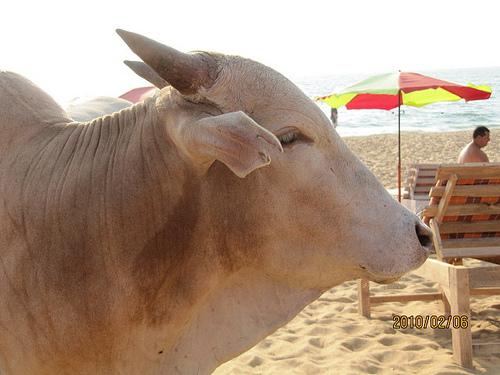What characteristics of the cow's horns are mentioned? The cow's horns are sharp and pointy. Identify the pieces of furniture located on the beach. There is a wooden beach chair and a lay out chair on the sand. What type of umbrella is present on the beach and what are its colors? A red and yellow beach umbrella is present on the beach. What type of date stamp is present in the image, and what are its components? There is a date stamp with the year 2010, the month 02, and the date 06. What animal is on the beach and what color is it? There is a large light brown cow on the beach. What interesting characteristics does the cow's ear have? The cow's ear has a piece clipped off. Describe the sandy area on the beach. The sandy area on the beach is soft and measures 157 pixels wide and 157 pixels tall. Which features of the cow's face are described in the image? The cow's eye, nostril, mouth, ear, and horns are described in the image. What is the primary task the human is performing in the image? The man is sitting on a bench at the beach. What are the missing elements on the man sitting on the beach? The man has dark hair and is not wearing a shirt. Describe the appearance of the man sitting on the bench. The man has dark hair and no shirt on. What is the number on the date stamp? 2010-02-06 What is the man sitting on at the beach? A wooden beach chair Which animal can be found on the beach in the image? Brown Brahma cow Write a sentence explaining the condition of the Brahma cow's ear. The Brahma cow's ear has a piece clipped off. What type of animal is on the beach, and how can you recognize it? A large and light brown Brahma cow with sharp pointy horns and a fatty deposit hump is on the beach. Which of the following materials make up the beach chair: plastic, wood or metal? Wood What are the unique features of the Brahma cow in the image? Sharp and pointy horns, clipped ear, pink nose with black nostril, white eyelashes, and a fatty deposit hump. What color is the umbrella on the beach? Yellow and red Is the umbrella in the image a beach umbrella? Provide a brief description of its appearance. Yes, it is a red and yellow beach umbrella. What is the man on the beach doing? The man is sitting on a wooden beach chair. In the image, what type of area is near the water? A soft sandy beach. Provide a brief statement explaining what can be seen in the distance in the image. There is water in the distance. Can you see an umbrella pole in the image, and if so, describe its appearance? Yes, the umbrella pole is tall and thin. Describe two objects besides the cow that you can see on the beach. There is a red and yellow umbrella and a wooden beach chair on the beach. Identify the body part of the cow with white colored features. The cow's eyelashes are white. Please describe the overall setting of the image. A big brown Brahma cow on a soft sandy beach with red and yellow beach umbrella, wooden chair, and a man sitting on it, with water in the distance. Describe the appearance of the cow's nose and nostril. The Brahma cow's nose is pink with a black nostril. 